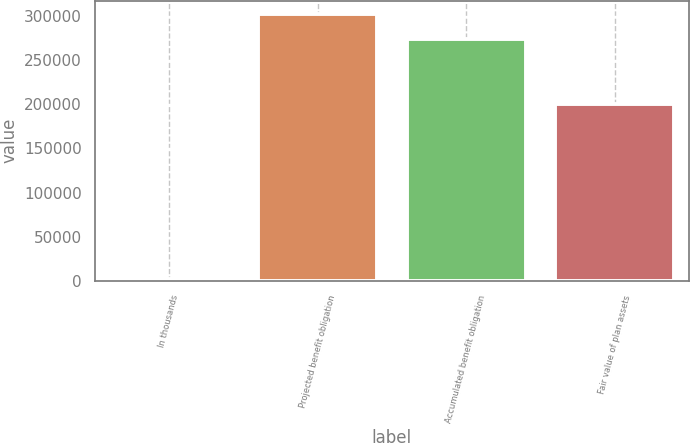<chart> <loc_0><loc_0><loc_500><loc_500><bar_chart><fcel>In thousands<fcel>Projected benefit obligation<fcel>Accumulated benefit obligation<fcel>Fair value of plan assets<nl><fcel>2017<fcel>302563<fcel>274557<fcel>200218<nl></chart> 